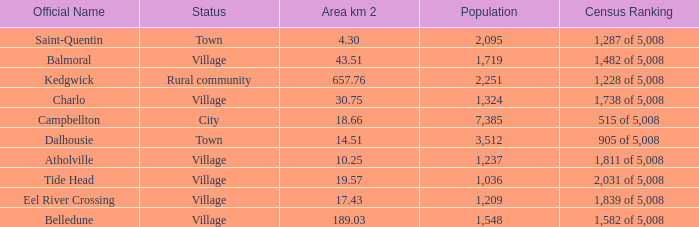When the communities name is Balmoral and the area is over 43.51 kilometers squared, what's the total population amount? 0.0. Would you be able to parse every entry in this table? {'header': ['Official Name', 'Status', 'Area km 2', 'Population', 'Census Ranking'], 'rows': [['Saint-Quentin', 'Town', '4.30', '2,095', '1,287 of 5,008'], ['Balmoral', 'Village', '43.51', '1,719', '1,482 of 5,008'], ['Kedgwick', 'Rural community', '657.76', '2,251', '1,228 of 5,008'], ['Charlo', 'Village', '30.75', '1,324', '1,738 of 5,008'], ['Campbellton', 'City', '18.66', '7,385', '515 of 5,008'], ['Dalhousie', 'Town', '14.51', '3,512', '905 of 5,008'], ['Atholville', 'Village', '10.25', '1,237', '1,811 of 5,008'], ['Tide Head', 'Village', '19.57', '1,036', '2,031 of 5,008'], ['Eel River Crossing', 'Village', '17.43', '1,209', '1,839 of 5,008'], ['Belledune', 'Village', '189.03', '1,548', '1,582 of 5,008']]} 